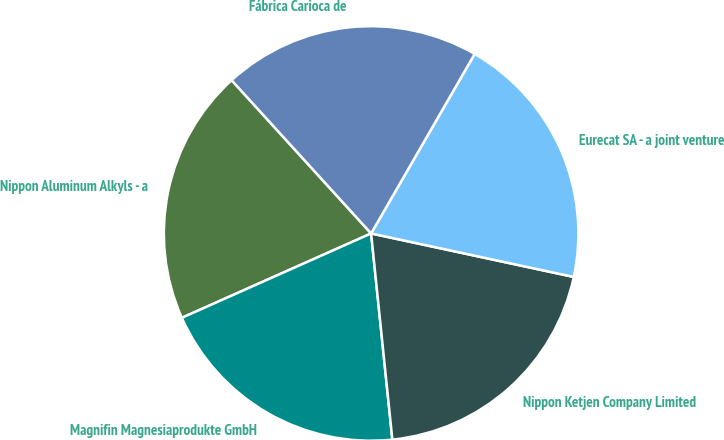Convert chart. <chart><loc_0><loc_0><loc_500><loc_500><pie_chart><fcel>Nippon Aluminum Alkyls - a<fcel>Magnifin Magnesiaprodukte GmbH<fcel>Nippon Ketjen Company Limited<fcel>Eurecat SA - a joint venture<fcel>Fábrica Carioca de<nl><fcel>19.92%<fcel>19.96%<fcel>20.0%<fcel>20.04%<fcel>20.08%<nl></chart> 